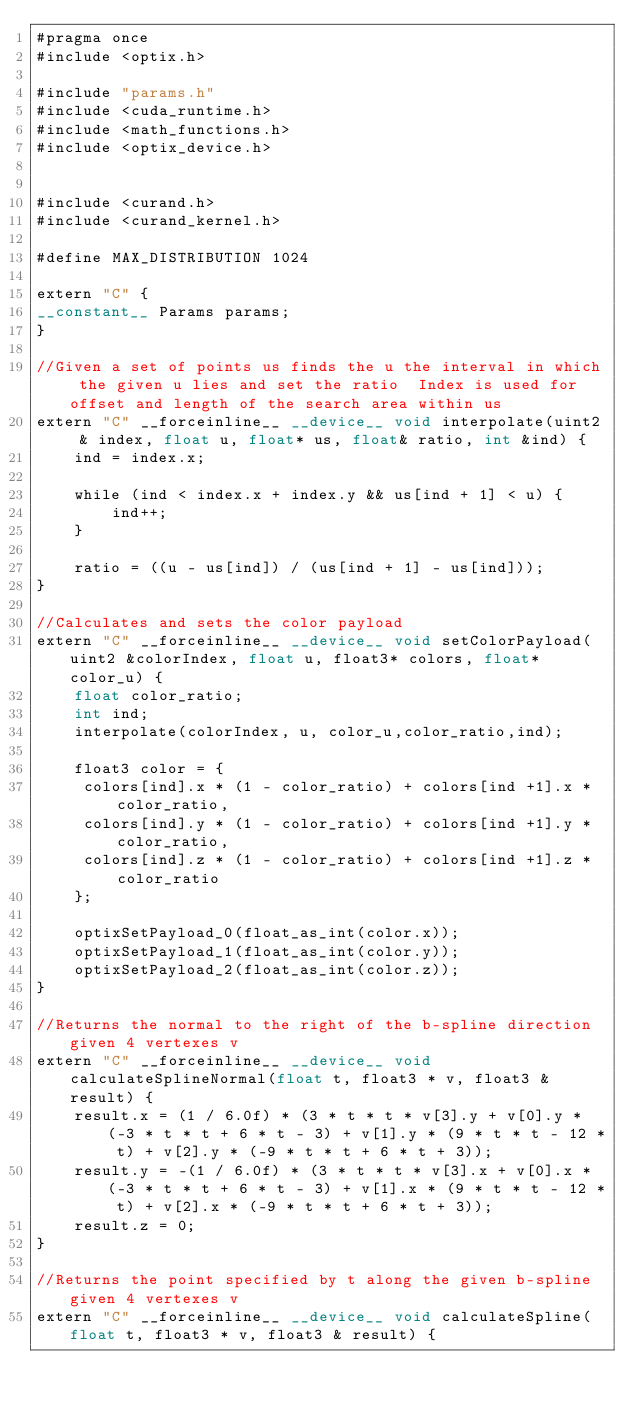Convert code to text. <code><loc_0><loc_0><loc_500><loc_500><_Cuda_>#pragma once
#include <optix.h>

#include "params.h"
#include <cuda_runtime.h>
#include <math_functions.h>
#include <optix_device.h>


#include <curand.h>
#include <curand_kernel.h>

#define MAX_DISTRIBUTION 1024

extern "C" {
__constant__ Params params;
}

//Given a set of points us finds the u the interval in which the given u lies and set the ratio  Index is used for offset and length of the search area within us
extern "C" __forceinline__ __device__ void interpolate(uint2 & index, float u, float* us, float& ratio, int &ind) {
    ind = index.x;

    while (ind < index.x + index.y && us[ind + 1] < u) {
        ind++;
    }

    ratio = ((u - us[ind]) / (us[ind + 1] - us[ind]));
}

//Calculates and sets the color payload
extern "C" __forceinline__ __device__ void setColorPayload(uint2 &colorIndex, float u, float3* colors, float* color_u) {
    float color_ratio;
    int ind;
    interpolate(colorIndex, u, color_u,color_ratio,ind);

    float3 color = {
     colors[ind].x * (1 - color_ratio) + colors[ind +1].x * color_ratio,
     colors[ind].y * (1 - color_ratio) + colors[ind +1].y * color_ratio,
     colors[ind].z * (1 - color_ratio) + colors[ind +1].z * color_ratio
    };

    optixSetPayload_0(float_as_int(color.x));
    optixSetPayload_1(float_as_int(color.y));
    optixSetPayload_2(float_as_int(color.z));
}

//Returns the normal to the right of the b-spline direction given 4 vertexes v
extern "C" __forceinline__ __device__ void calculateSplineNormal(float t, float3 * v, float3 & result) {
    result.x = (1 / 6.0f) * (3 * t * t * v[3].y + v[0].y * (-3 * t * t + 6 * t - 3) + v[1].y * (9 * t * t - 12 * t) + v[2].y * (-9 * t * t + 6 * t + 3));
    result.y = -(1 / 6.0f) * (3 * t * t * v[3].x + v[0].x * (-3 * t * t + 6 * t - 3) + v[1].x * (9 * t * t - 12 * t) + v[2].x * (-9 * t * t + 6 * t + 3));
    result.z = 0;
}

//Returns the point specified by t along the given b-spline given 4 vertexes v
extern "C" __forceinline__ __device__ void calculateSpline(float t, float3 * v, float3 & result) {</code> 